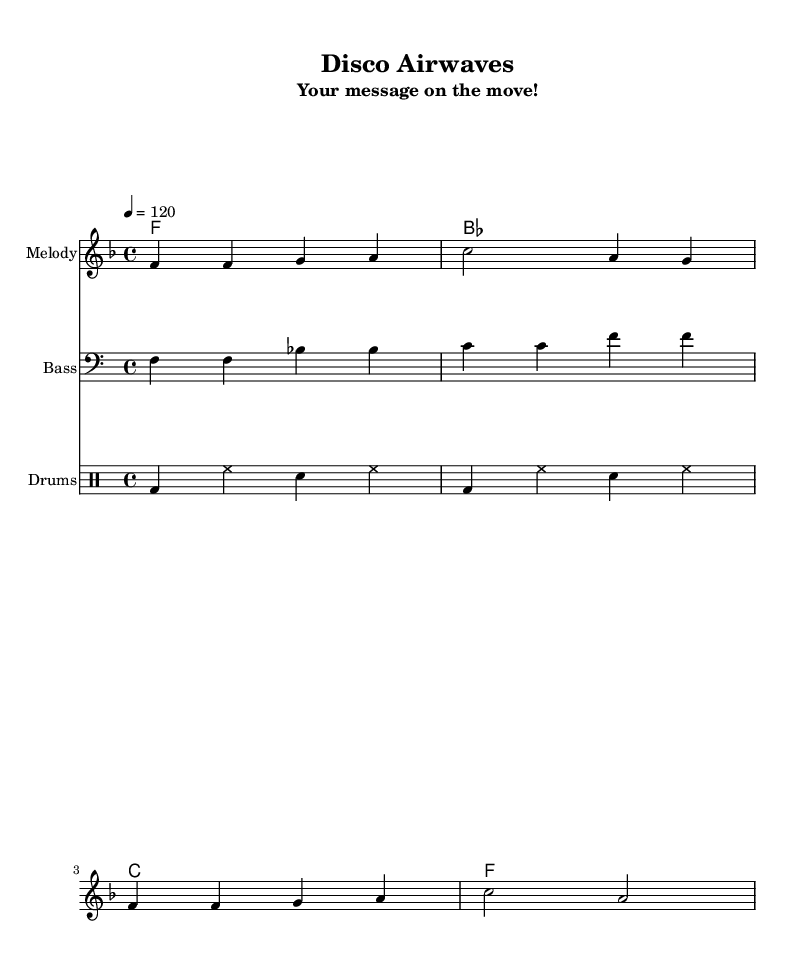What is the key signature of this music? The key signature indicated in the piece is F major, which has one flat (B flat). This can be identified at the beginning of the music sheet where the key signature is displayed.
Answer: F major What is the time signature of this music? The time signature can be found in the opening section of the sheet music, where it shows a "4/4" indication. This means there are four beats in each measure and the quarter note receives one beat.
Answer: 4/4 What is the tempo marking for this piece? The tempo marking in the sheet music is indicated as "4 = 120," which means the quarter note should be played at a speed of 120 beats per minute. This is also known as the metronome marking.
Answer: 120 How many measures are in the melody? Counting the measures in the melody section, there are four measures shown in the melody line. This includes the notes and their rhythmic structure illustrated on the staff.
Answer: 4 What is the bass clef root note of the first measure? The first measure of the bass clef clearly shows the note F as its root, which is a fundamental note in this section and aligns with the harmony.
Answer: F What type of pattern is represented in the drum section? The drum section features a basic pattern that includes a kick drum (bd), hi-hat (hh), and snare (sn). This pattern is repeated in a typical disco style rhythm.
Answer: Basic Which chord is played in the third measure of the harmonies? The third measure of the harmonies indicates a C major chord, which is represented symbolically by the letter C. This chord contributes to the overall harmonic structure of the piece.
Answer: C 